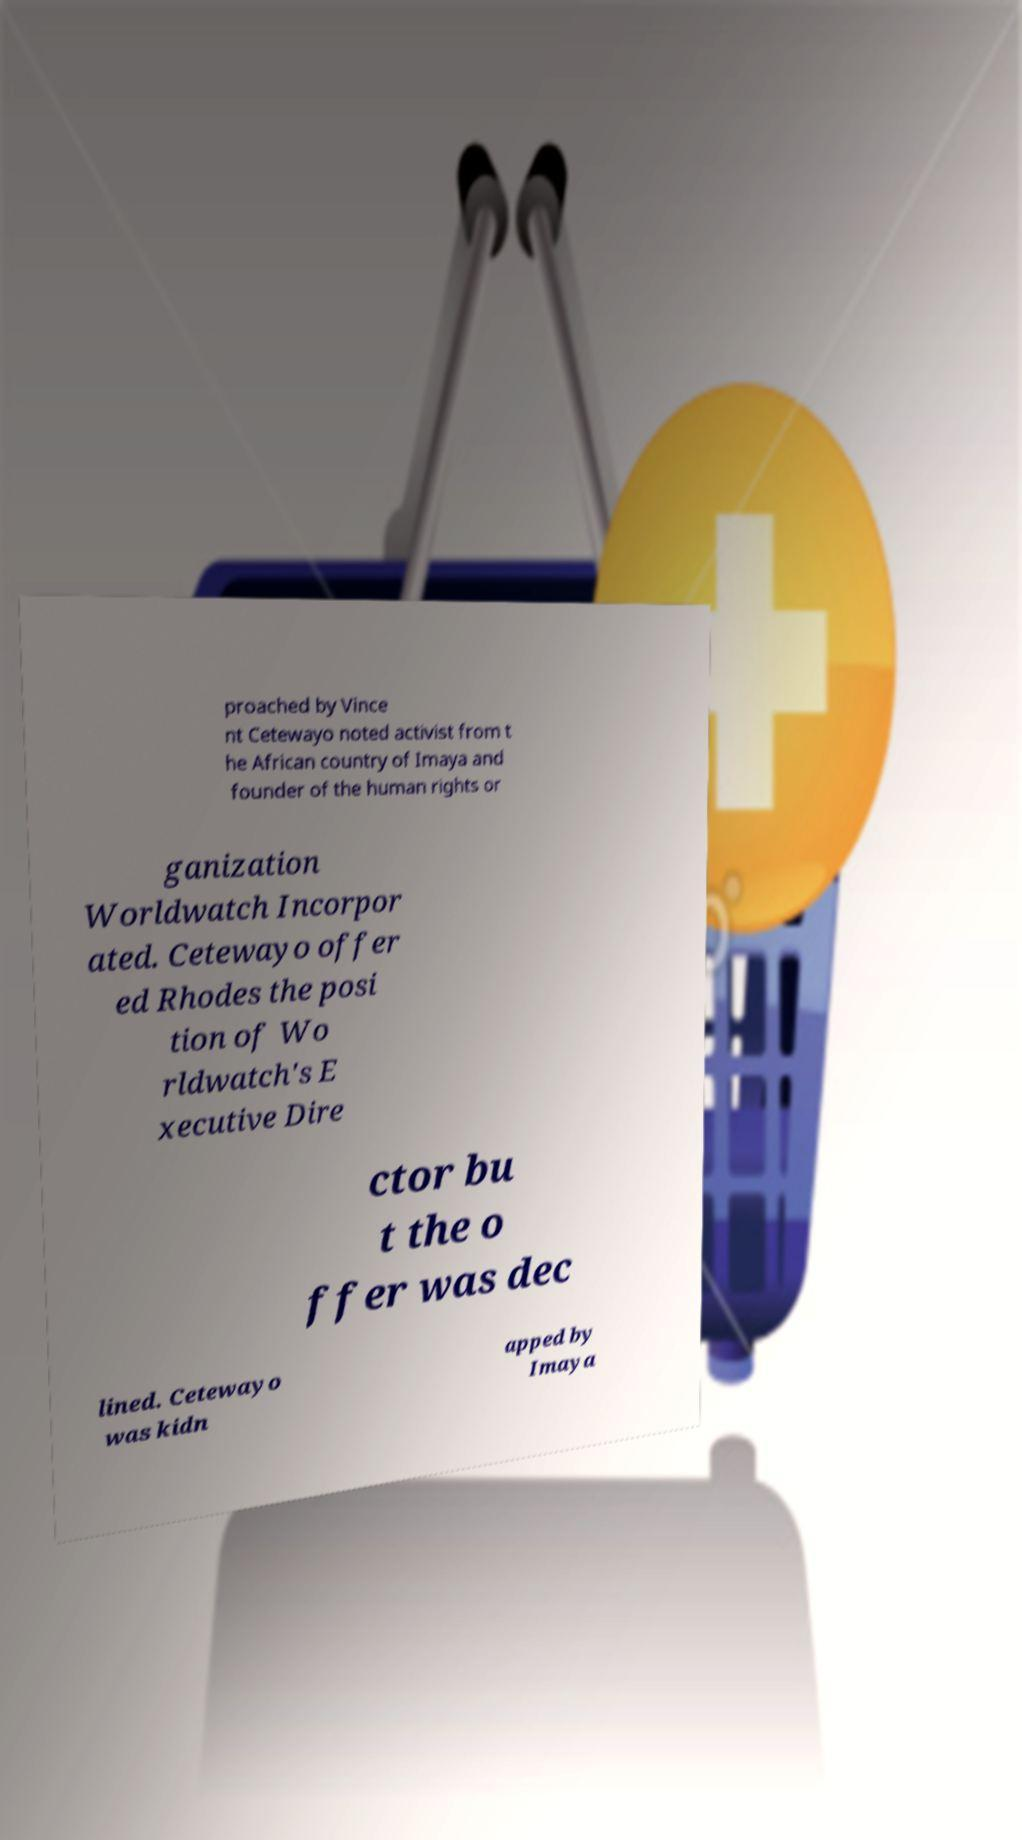What messages or text are displayed in this image? I need them in a readable, typed format. proached by Vince nt Cetewayo noted activist from t he African country of Imaya and founder of the human rights or ganization Worldwatch Incorpor ated. Cetewayo offer ed Rhodes the posi tion of Wo rldwatch's E xecutive Dire ctor bu t the o ffer was dec lined. Cetewayo was kidn apped by Imaya 